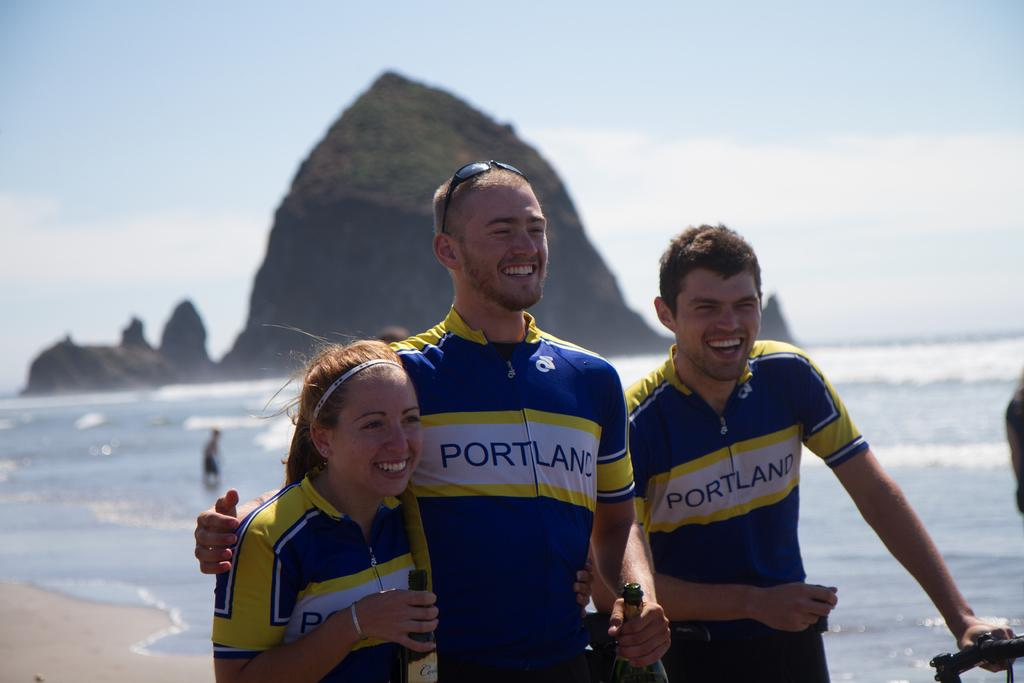What are the people in the image doing? The people in the image are standing in the middle of the image and holding bottles. What is the mood of the people in the image? The people in the image are smiling, which suggests a positive mood. What is visible behind the people? There is water visible behind the people. What is the landscape feature behind the water? There is a hill behind the water. What is visible at the top of the image? There are clouds and sky visible at the top of the image. Are there any cherries growing on the hill in the image? There is no mention of cherries or any fruit trees in the image; it only shows people standing, holding bottles, and the surrounding landscape. 